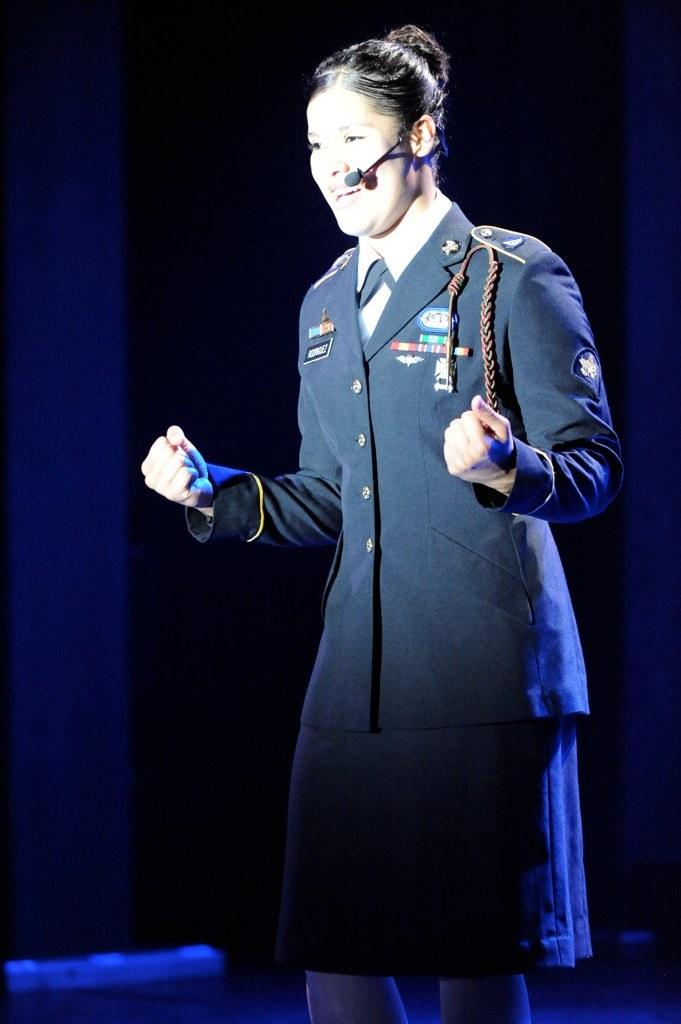Who is the main subject in the image? There is a woman in the image. What is the woman wearing? The woman is wearing a shirt and a mic. What is the woman doing in the image? The woman is speaking. Where is the woman located in the image? The woman is standing on a stage. What is the color of the background in the image? The background of the image is dark in color. What type of trick is the woman performing in the image? There is no trick being performed in the image; the woman is simply speaking on stage. What color is the silver shade in the image? There is no silver shade present in the image. 